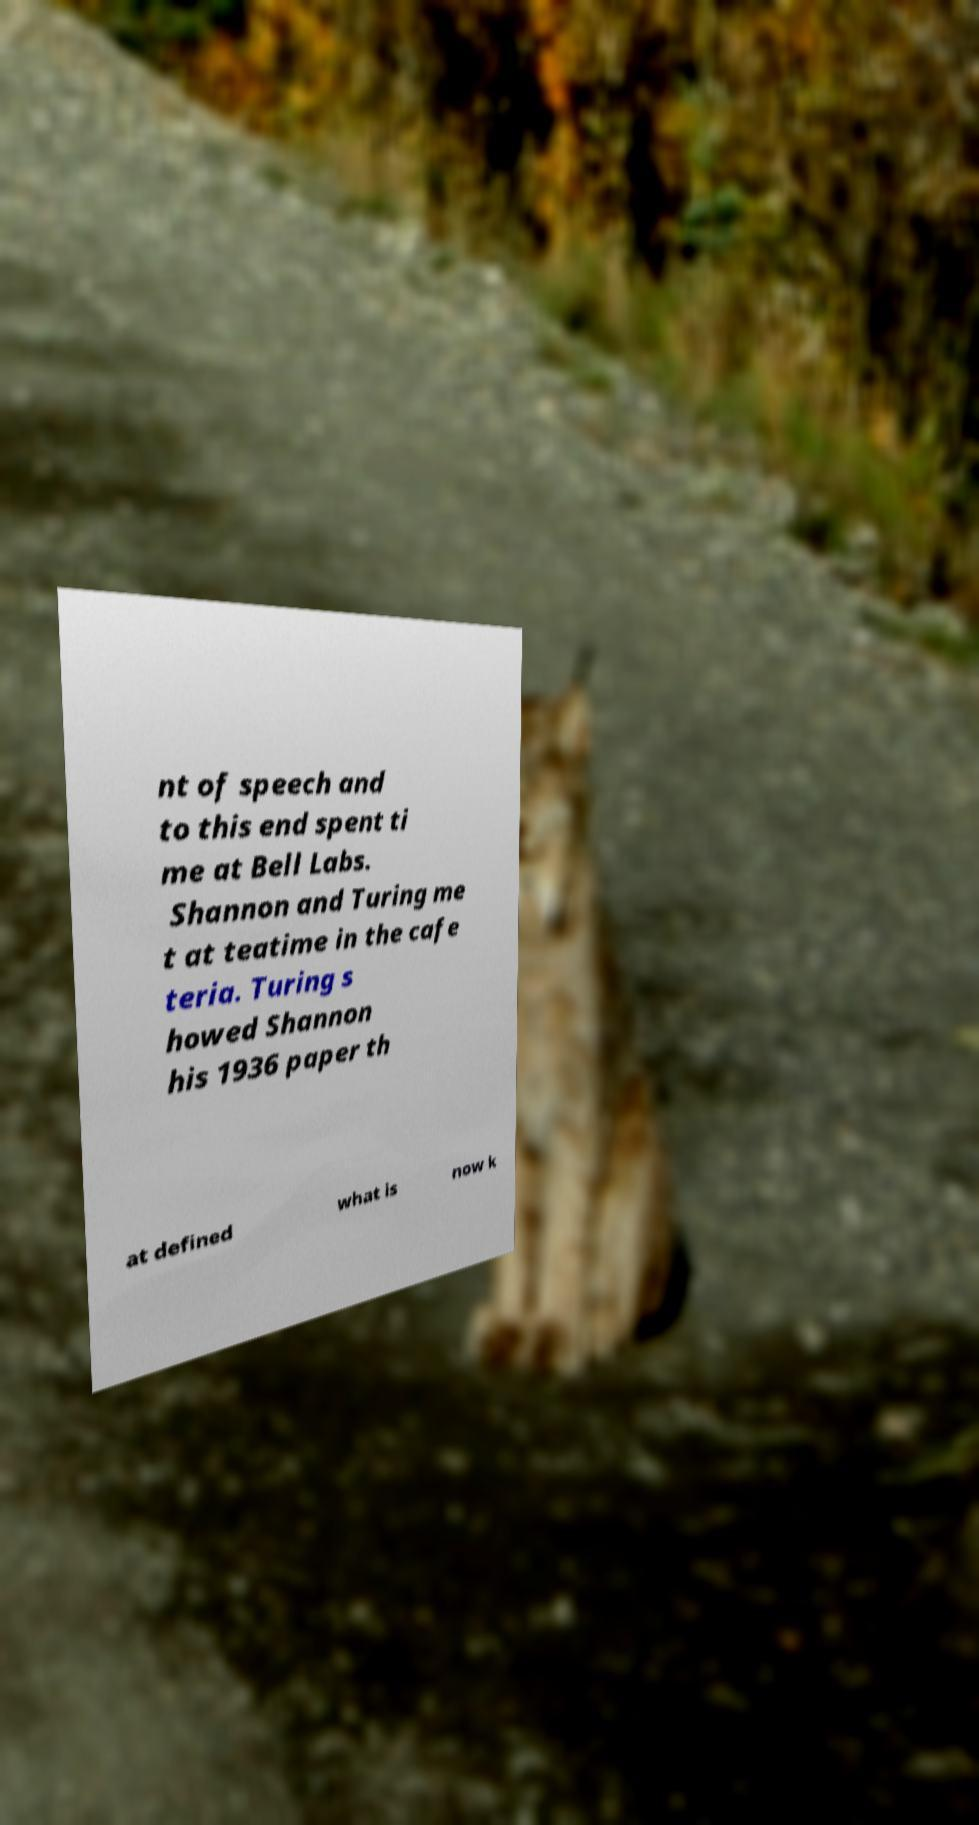Please identify and transcribe the text found in this image. nt of speech and to this end spent ti me at Bell Labs. Shannon and Turing me t at teatime in the cafe teria. Turing s howed Shannon his 1936 paper th at defined what is now k 